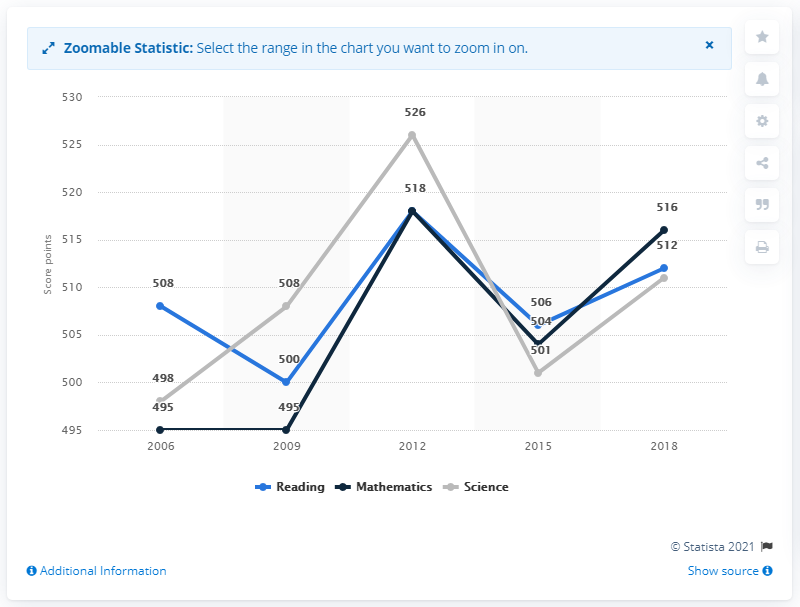Point out several critical features in this image. In the most recent testing of mathematics skills among 15-year-olds in Poland, the results showed that the students scored a total of 516 points. 